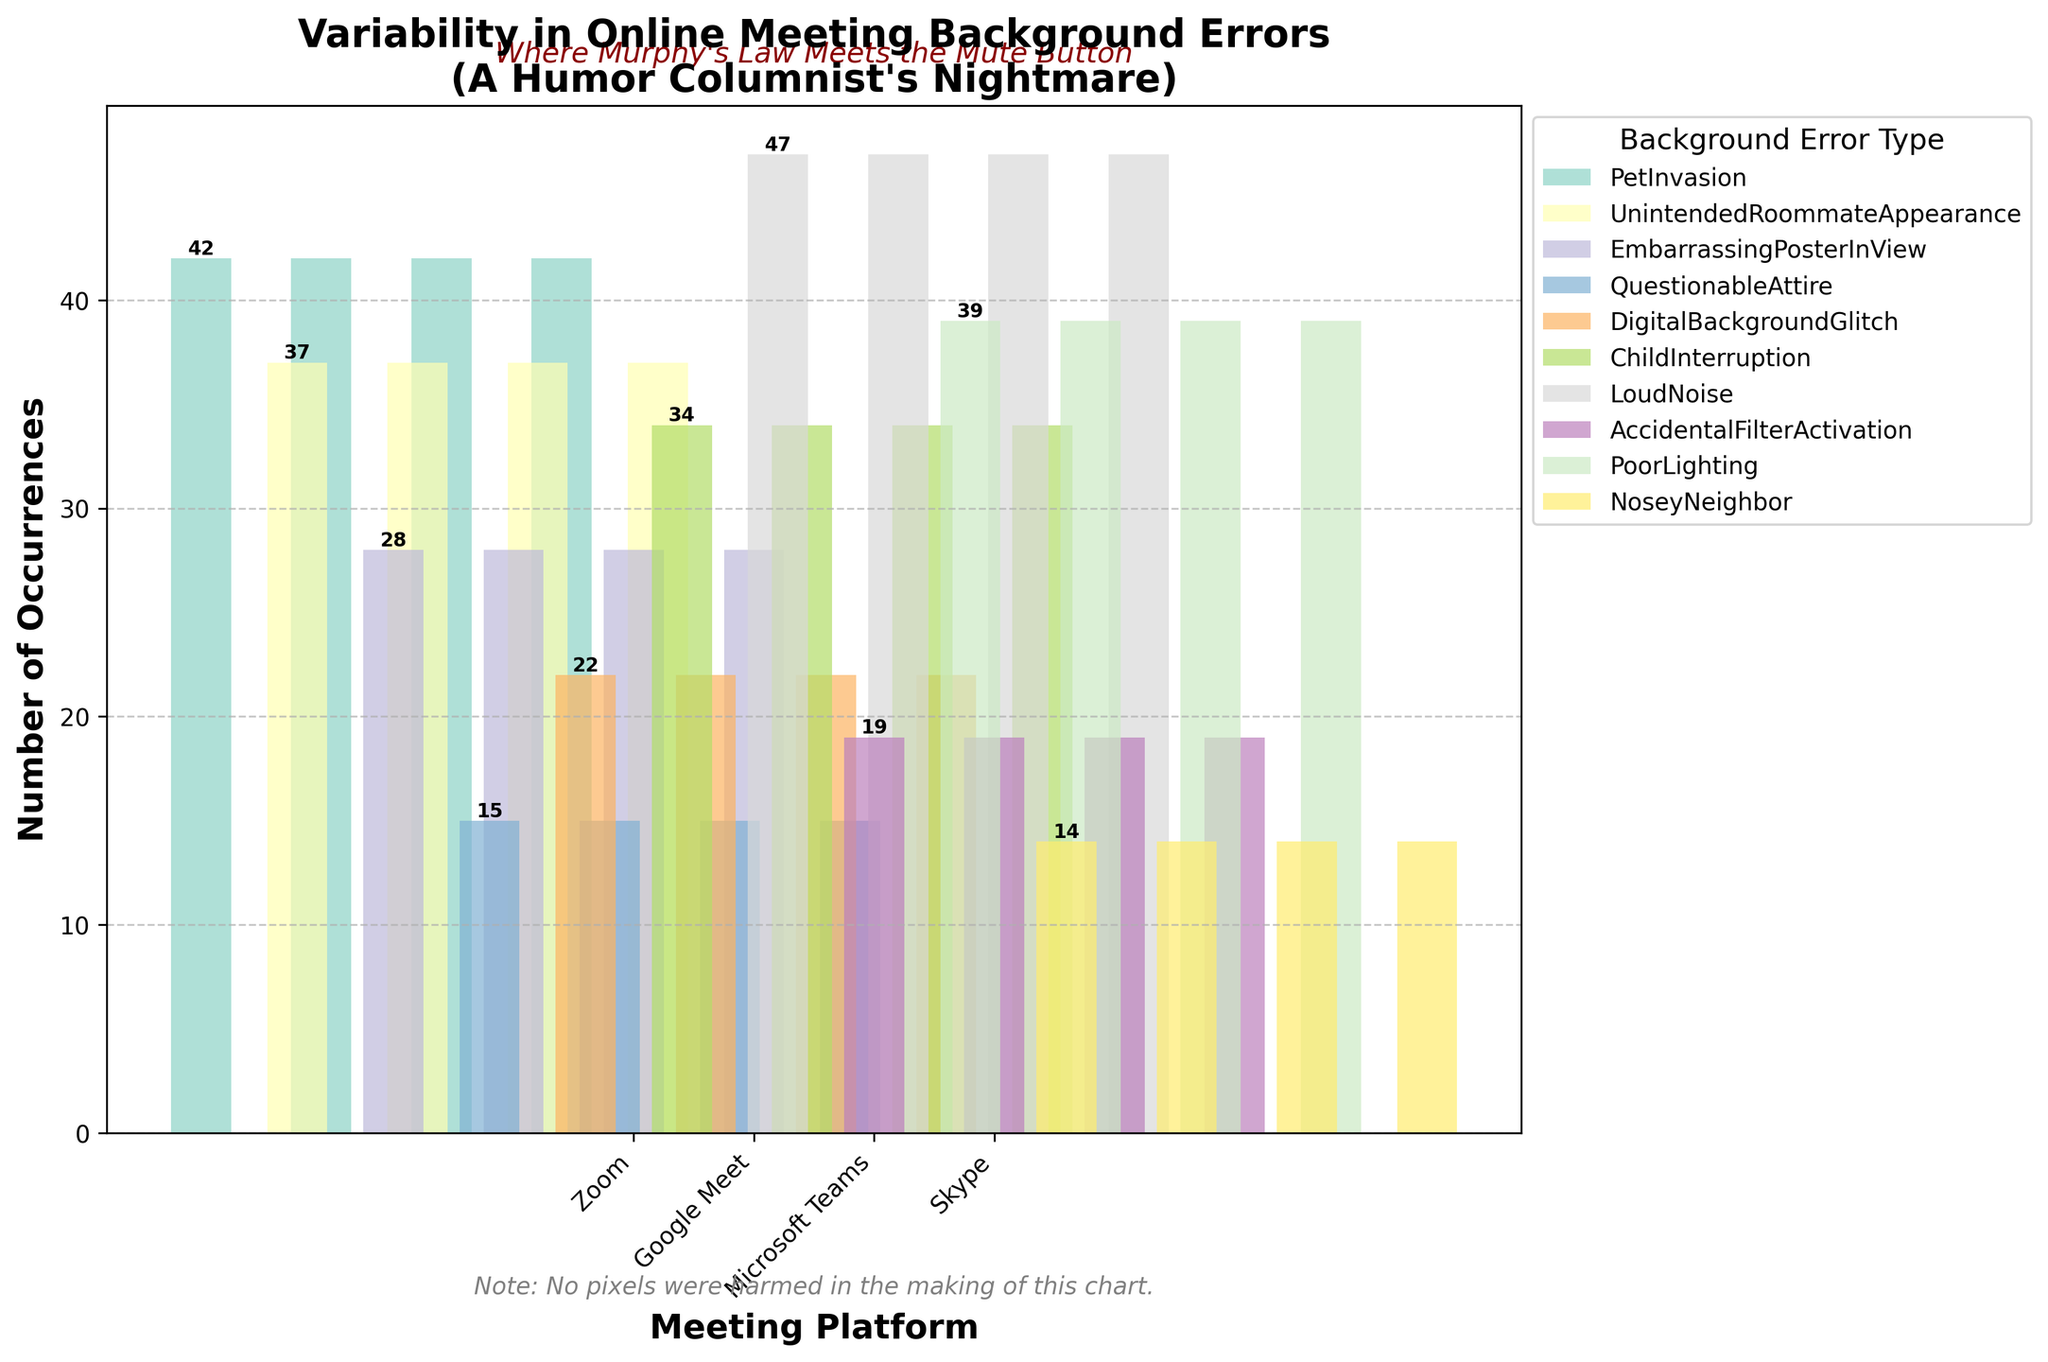What is the title of the plot? The plot's title is usually displayed prominently at the top of the chart. Here, it reads "Variability in Online Meeting Background Errors" with a subtitle "A Humor Columnist's Nightmare".
Answer: Variability in Online Meeting Background Errors Which platform has the highest number of instances of 'Loud Noise'? To find this, look for the 'Loud Noise' error type and identify the corresponding platform with the highest bar. The color associated with 'Loud Noise' legend helps identify this on the chart.
Answer: Google Meet Which background error type has the fewest occurrences in 'Zoom' meetings? We locate the segments of the plot corresponding to 'Zoom' and compare the heights. 'Nosey Neighbor' is not present in the chart. Hence, the smallest value among 'Pet Invasion', 'Questionable Attire', and 'Accidental Filter Activation' shows that 'Questionable Attire' has the fewest instances.
Answer: Questionable Attire What is the sum of occurrences for 'Embarrassing Poster In View' across all platforms? We need to add the occurrences of 'Embarrassing Poster In View' error type present over different platforms. In this case, it's only on 'Microsoft Teams' with a count of 28.
Answer: 28 Which error type appears only on a single platform and on which platform does it occur? Observe the color-coded bars for error types uniquely present on one platform. 'Nosey Neighbor' appears only on 'Google Meet' and no other platform.
Answer: Nosey Neighbor, Google Meet Which platform has the widest bars overall? The width of the bars is proportional to the number of occurrences for each error type. By visually inspecting the plot, 'Google Meet' appears to have the widest bars overall due to high occurrences like 'Loud Noise' and others.
Answer: Google Meet Between 'Microsoft Teams' and 'Skype', which platform has more total occurrences of background errors? Summing up the number of occurrences for each error type for 'Microsoft Teams' (Child Interruption (34), Embarrassing Poster In View (28)) and 'Skype' (Digital Background Glitch (22), Poor Lighting (39)), the calculated totals are compared.
Answer: Microsoft Teams For 'Google Meet,' how many more occurrences are there of 'Loud Noise' than 'Unintended Roommate Appearance'? First, find the bar heights for 'Loud Noise' (47) and 'Unintended Roommate Appearance' (37), then compute the difference: 47 - 37 = 10.
Answer: 10 What is the difference between the highest and lowest number of occurrences for 'Zoom' errors? Find the maximum ('Pet Invasion' with 42) and minimum ('Questionable Attire' with 15) values for 'Zoom' and subtract: 42 - 15 = 27.
Answer: 27 